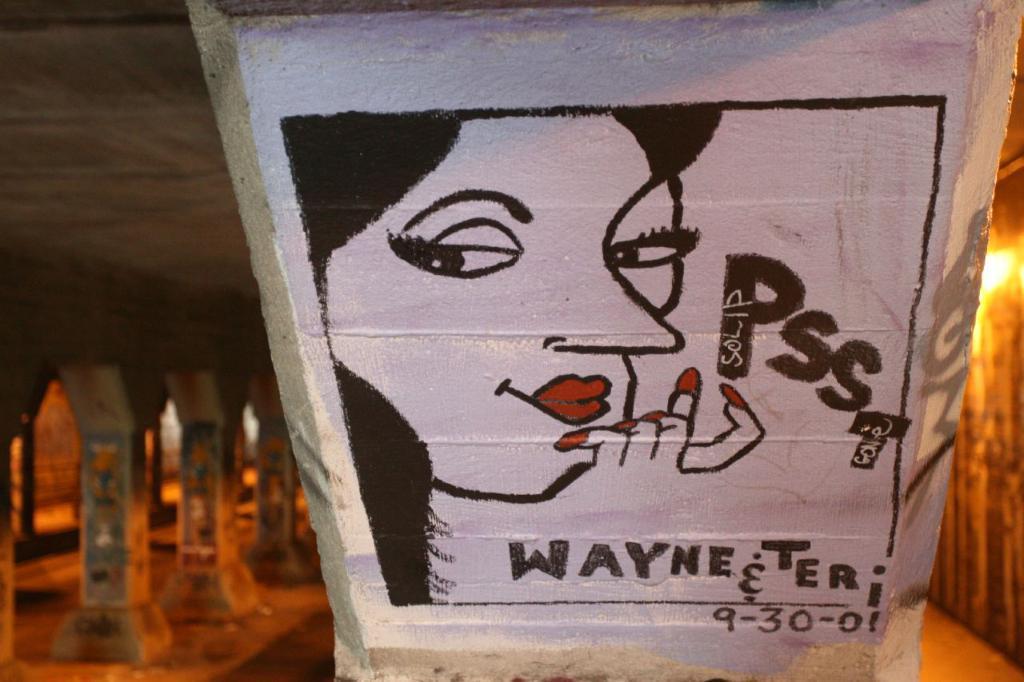Describe this image in one or two sentences. In the foreground I can see a wall painting, pillars, light and a palace. This image is taken may be during night. 